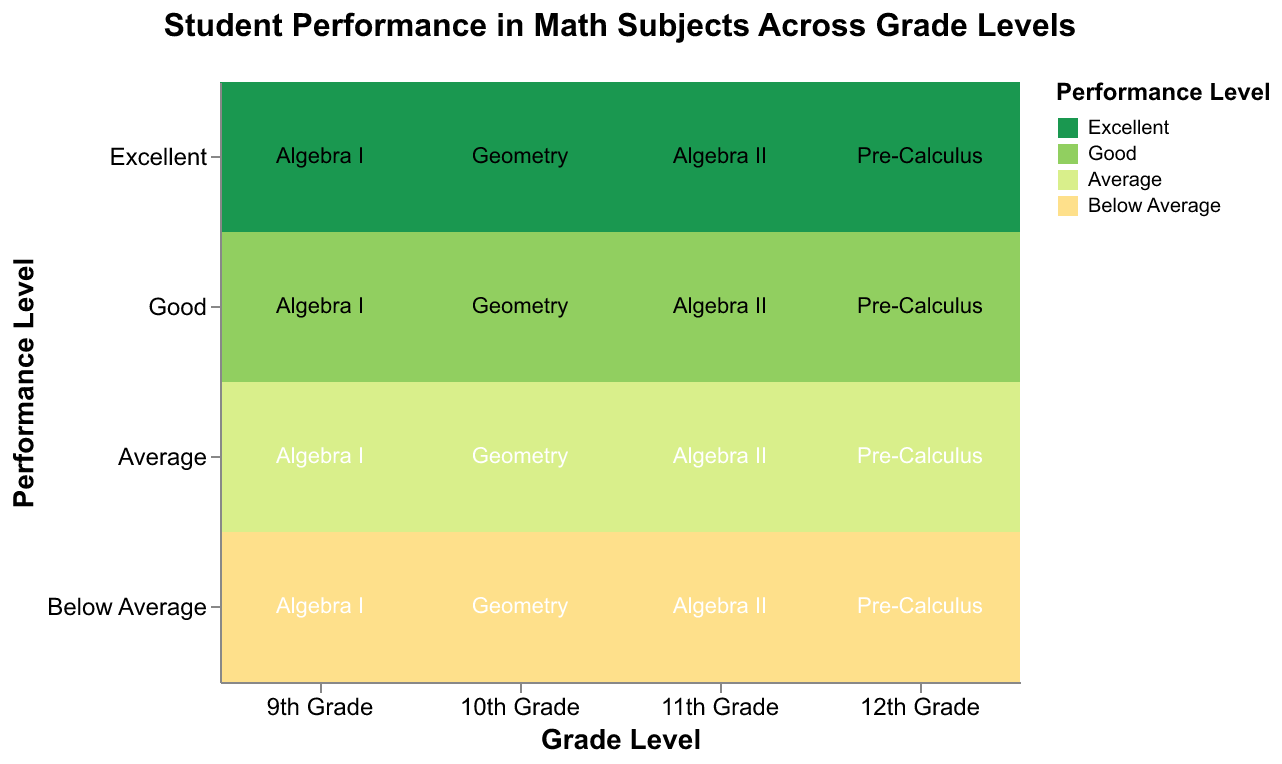What's the title of the figure? The title is displayed at the top of the chart. It reads "Student Performance in Math Subjects Across Grade Levels."
Answer: Student Performance in Math Subjects Across Grade Levels What does the x-axis represent? The x-axis label clearly states "Grade Level." It categorizes the data by different grades: 9th Grade, 10th Grade, 11th Grade, and 12th Grade.
Answer: Grade Level Which grade level has the highest number of students rated as "Good" in their math subject? By visual inspection, the 10th Grade (Geometry) has the widest segment for the "Good" performance level, indicating it has the highest number.
Answer: 10th Grade What is the count of students achieving an "Excellent" performance level in 11th Grade Algebra II? The 11th Grade Algebra II section under the "Excellent" performance level shows a count of 32 students in the data.
Answer: 32 Which math subject has the lowest number of students rated as "Below Average"? By examining the chart, 12th Grade Pre-Calculus has the smallest area for the "Below Average" performance level, indicating the lowest count.
Answer: Pre-Calculus Compare the number of students rated "Excellent" in 9th Grade Algebra I and 10th Grade Geometry. The data shows 45 students rated "Excellent" in 9th Grade Algebra I and 38 students in 10th Grade Geometry. Comparing, 9th Grade Algebra I has more students.
Answer: 9th Grade Algebra I Which grade has the most evenly distributed performance levels? By observing the balance in the width of the segments, the 11th Grade Algebra II appears to have a more balanced distribution across performance levels than the others.
Answer: 11th Grade What is the total number of students in 12th Grade Pre-Calculus? Summing up the counts for all performance levels in 12th Grade Pre-Calculus: 25 (Excellent) + 62 (Good) + 76 (Average) + 17 (Below Average) = 180 students.
Answer: 180 Which performance level color represents "Average"? The "Average" performance level is represented using a yellow-green color on the plot.
Answer: Yellow-green Compare the sum of students rated "Good" in 9th Grade Algebra I and 11th Grade Algebra II. The counts are 78 for 9th Grade Algebra I and 71 for 11th Grade Algebra II. Summing these numbers: 78 + 71 = 149 students.
Answer: 149 